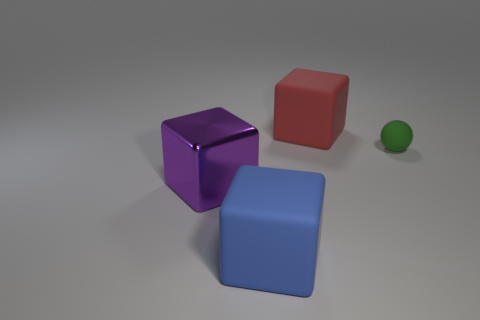The large block that is made of the same material as the big blue object is what color? The question seems to be based on an incorrect assumption, as there is no large block in the image that is made from the same material as another large object but differs in color. However, if we're referring to the block that appears most similar in shape and size to the blue one, it is purple, not red as the original answer stated. 